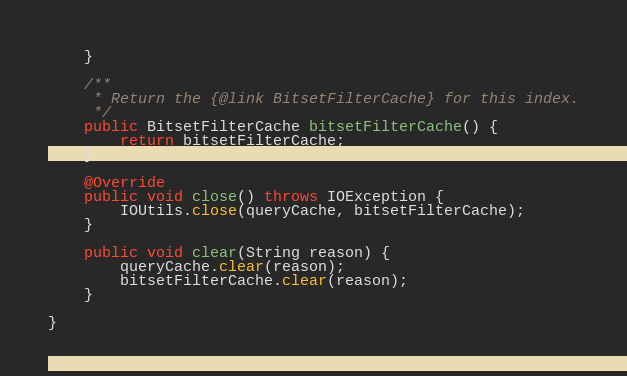Convert code to text. <code><loc_0><loc_0><loc_500><loc_500><_Java_>    }

    /**
     * Return the {@link BitsetFilterCache} for this index.
     */
    public BitsetFilterCache bitsetFilterCache() {
        return bitsetFilterCache;
    }

    @Override
    public void close() throws IOException {
        IOUtils.close(queryCache, bitsetFilterCache);
    }

    public void clear(String reason) {
        queryCache.clear(reason);
        bitsetFilterCache.clear(reason);
    }

}
</code> 